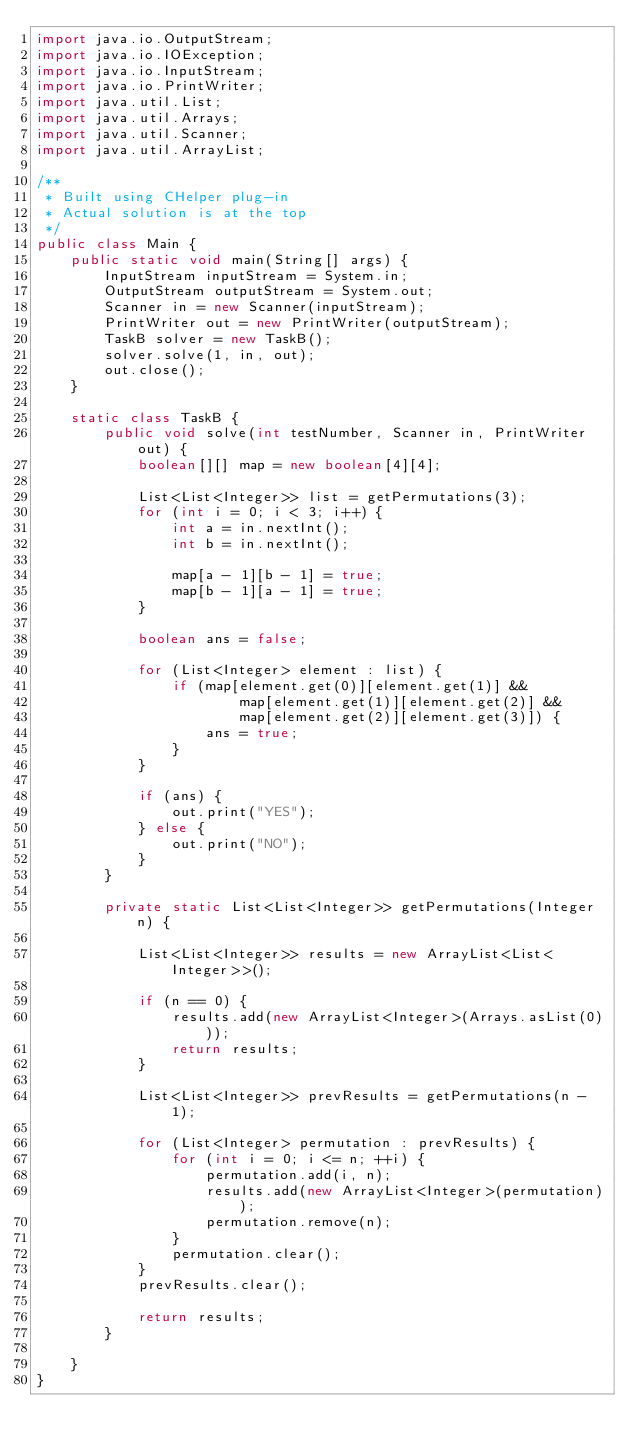<code> <loc_0><loc_0><loc_500><loc_500><_Java_>import java.io.OutputStream;
import java.io.IOException;
import java.io.InputStream;
import java.io.PrintWriter;
import java.util.List;
import java.util.Arrays;
import java.util.Scanner;
import java.util.ArrayList;

/**
 * Built using CHelper plug-in
 * Actual solution is at the top
 */
public class Main {
    public static void main(String[] args) {
        InputStream inputStream = System.in;
        OutputStream outputStream = System.out;
        Scanner in = new Scanner(inputStream);
        PrintWriter out = new PrintWriter(outputStream);
        TaskB solver = new TaskB();
        solver.solve(1, in, out);
        out.close();
    }

    static class TaskB {
        public void solve(int testNumber, Scanner in, PrintWriter out) {
            boolean[][] map = new boolean[4][4];

            List<List<Integer>> list = getPermutations(3);
            for (int i = 0; i < 3; i++) {
                int a = in.nextInt();
                int b = in.nextInt();

                map[a - 1][b - 1] = true;
                map[b - 1][a - 1] = true;
            }

            boolean ans = false;

            for (List<Integer> element : list) {
                if (map[element.get(0)][element.get(1)] &&
                        map[element.get(1)][element.get(2)] &&
                        map[element.get(2)][element.get(3)]) {
                    ans = true;
                }
            }

            if (ans) {
                out.print("YES");
            } else {
                out.print("NO");
            }
        }

        private static List<List<Integer>> getPermutations(Integer n) {

            List<List<Integer>> results = new ArrayList<List<Integer>>();

            if (n == 0) {
                results.add(new ArrayList<Integer>(Arrays.asList(0)));
                return results;
            }

            List<List<Integer>> prevResults = getPermutations(n - 1);

            for (List<Integer> permutation : prevResults) {
                for (int i = 0; i <= n; ++i) {
                    permutation.add(i, n);
                    results.add(new ArrayList<Integer>(permutation));
                    permutation.remove(n);
                }
                permutation.clear();
            }
            prevResults.clear();

            return results;
        }

    }
}

</code> 